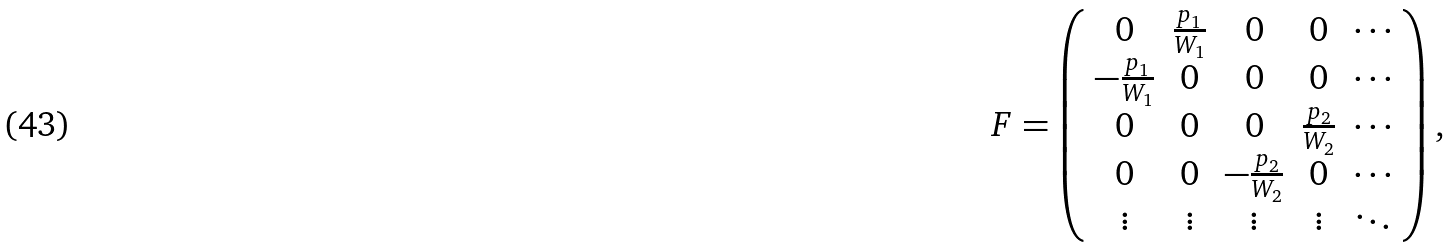<formula> <loc_0><loc_0><loc_500><loc_500>F = \left ( \begin{array} { c c c c c } 0 & \frac { p _ { 1 } } { W _ { 1 } } & 0 & 0 & \cdots \\ - \frac { p _ { 1 } } { W _ { 1 } } & 0 & 0 & 0 & \cdots \\ 0 & 0 & 0 & \frac { p _ { 2 } } { W _ { 2 } } & \cdots \\ 0 & 0 & - \frac { p _ { 2 } } { W _ { 2 } } & 0 & \cdots \\ \vdots & \vdots & \vdots & \vdots & \ddots \end{array} \right ) ,</formula> 